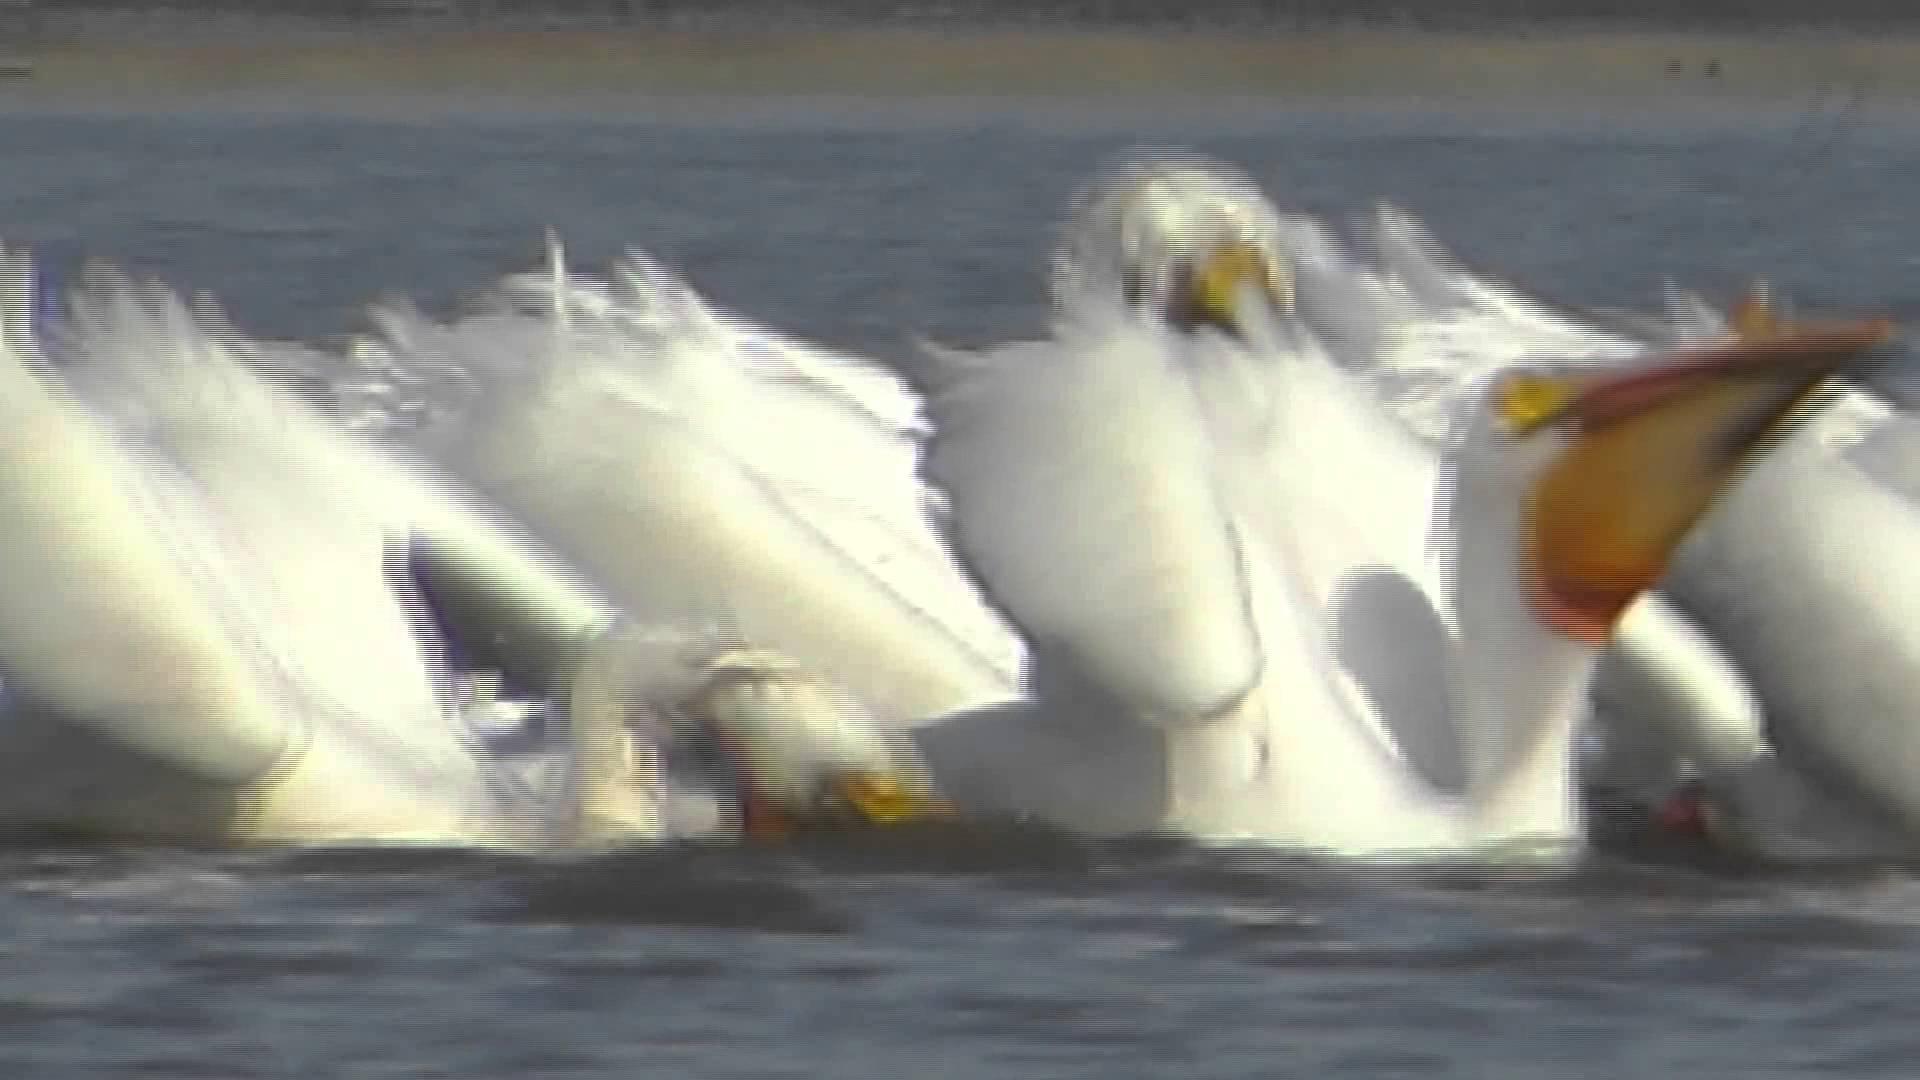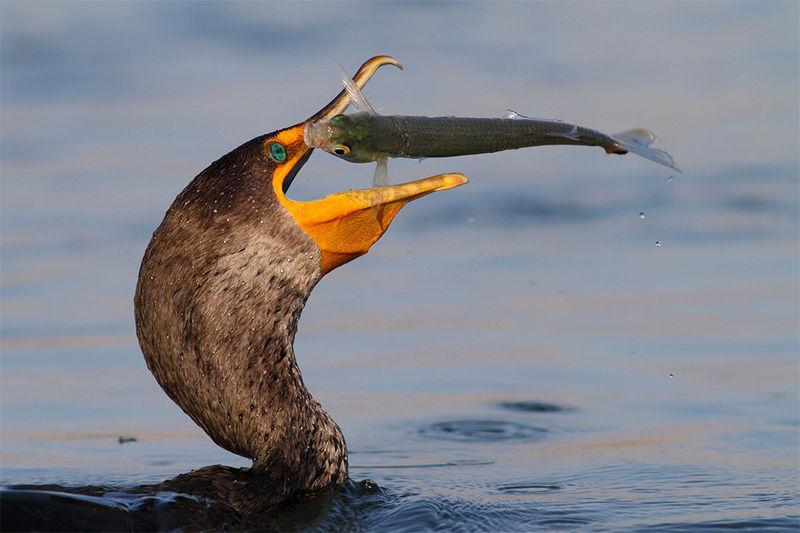The first image is the image on the left, the second image is the image on the right. Considering the images on both sides, is "At least one of the birds has a fish in its mouth." valid? Answer yes or no. Yes. The first image is the image on the left, the second image is the image on the right. Evaluate the accuracy of this statement regarding the images: "The bird in the right image is eating a fish.". Is it true? Answer yes or no. Yes. 